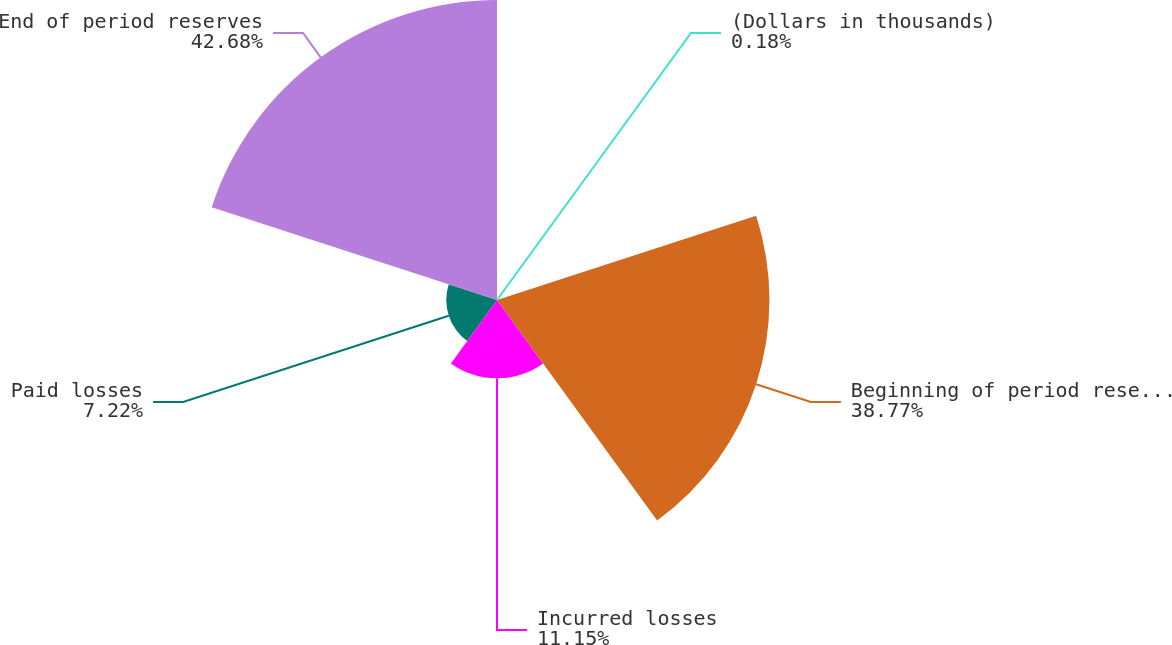Convert chart to OTSL. <chart><loc_0><loc_0><loc_500><loc_500><pie_chart><fcel>(Dollars in thousands)<fcel>Beginning of period reserves<fcel>Incurred losses<fcel>Paid losses<fcel>End of period reserves<nl><fcel>0.18%<fcel>38.77%<fcel>11.15%<fcel>7.22%<fcel>42.69%<nl></chart> 